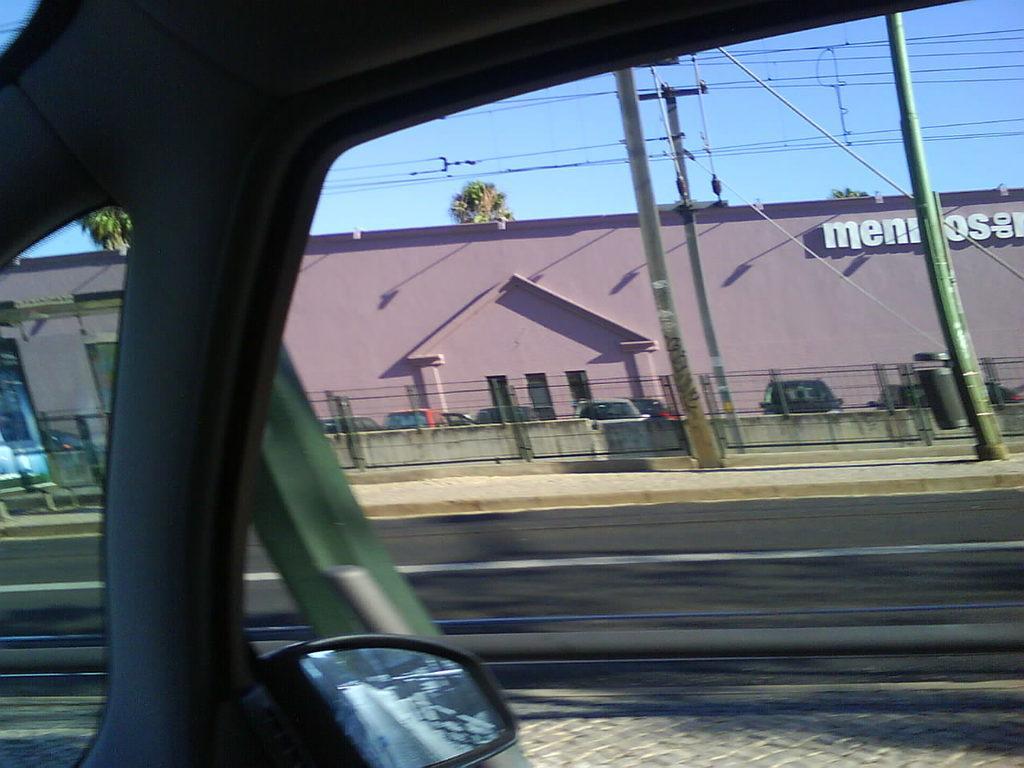Can you describe this image briefly? In this image we can see a vehicle with mirror and glass. Through the glass, we can see the wall with fence and vehicles on the ground. And we can see the building with text. In the background, we can see the trees and sky. 